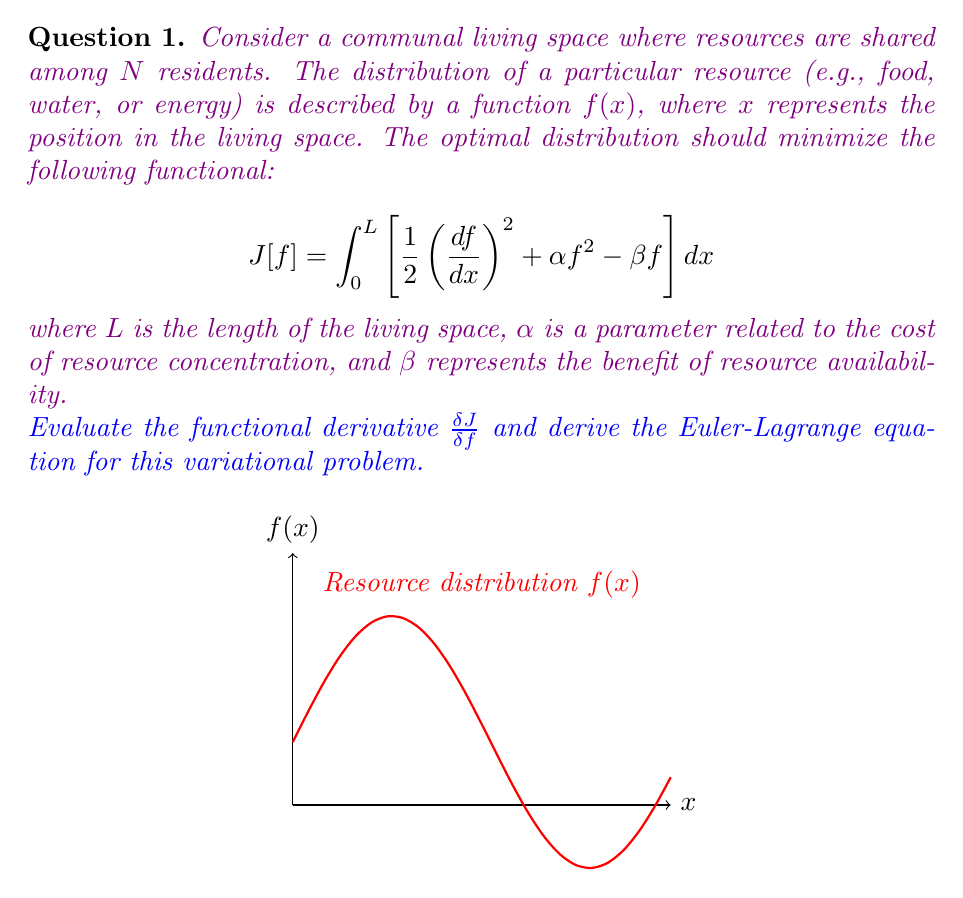Teach me how to tackle this problem. To solve this variational problem, we need to follow these steps:

1) The functional derivative is defined as:

   $$\frac{\delta J}{\delta f} = \frac{\partial F}{\partial f} - \frac{d}{dx}\left(\frac{\partial F}{\partial f'}\right)$$

   where $F$ is the integrand of our functional $J[f]$.

2) In our case, 
   $$F = \frac{1}{2}\left(\frac{df}{dx}\right)^2 + \alpha f^2 - \beta f$$

3) Let's calculate the partial derivatives:

   $$\frac{\partial F}{\partial f} = 2\alpha f - \beta$$
   $$\frac{\partial F}{\partial f'} = \frac{df}{dx}$$

4) Now, we need to calculate $\frac{d}{dx}\left(\frac{\partial F}{\partial f'}\right)$:

   $$\frac{d}{dx}\left(\frac{\partial F}{\partial f'}\right) = \frac{d}{dx}\left(\frac{df}{dx}\right) = \frac{d^2f}{dx^2}$$

5) Substituting these into the functional derivative equation:

   $$\frac{\delta J}{\delta f} = 2\alpha f - \beta - \frac{d^2f}{dx^2}$$

6) The Euler-Lagrange equation states that for an optimal solution, the functional derivative should be zero:

   $$\frac{\delta J}{\delta f} = 0$$

7) Therefore, the Euler-Lagrange equation for this problem is:

   $$2\alpha f - \beta - \frac{d^2f}{dx^2} = 0$$

8) Rearranging this equation:

   $$\frac{d^2f}{dx^2} - 2\alpha f = -\beta$$

This is a second-order linear differential equation that describes the optimal resource distribution in the communal living space.
Answer: $\frac{\delta J}{\delta f} = 2\alpha f - \beta - \frac{d^2f}{dx^2}$; Euler-Lagrange equation: $\frac{d^2f}{dx^2} - 2\alpha f = -\beta$ 